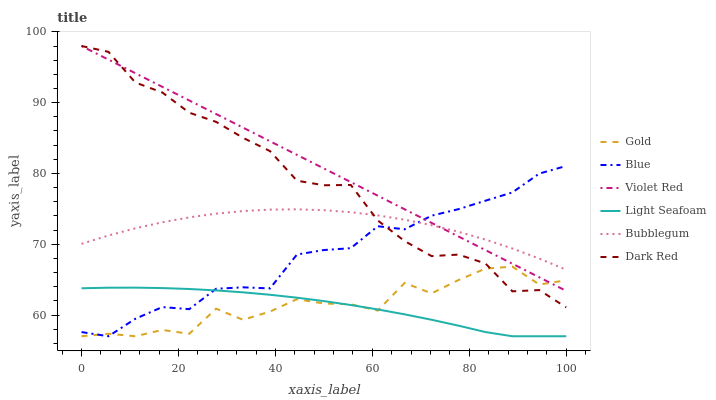Does Gold have the minimum area under the curve?
Answer yes or no. No. Does Gold have the maximum area under the curve?
Answer yes or no. No. Is Gold the smoothest?
Answer yes or no. No. Is Violet Red the roughest?
Answer yes or no. No. Does Violet Red have the lowest value?
Answer yes or no. No. Does Gold have the highest value?
Answer yes or no. No. Is Light Seafoam less than Dark Red?
Answer yes or no. Yes. Is Violet Red greater than Light Seafoam?
Answer yes or no. Yes. Does Light Seafoam intersect Dark Red?
Answer yes or no. No. 